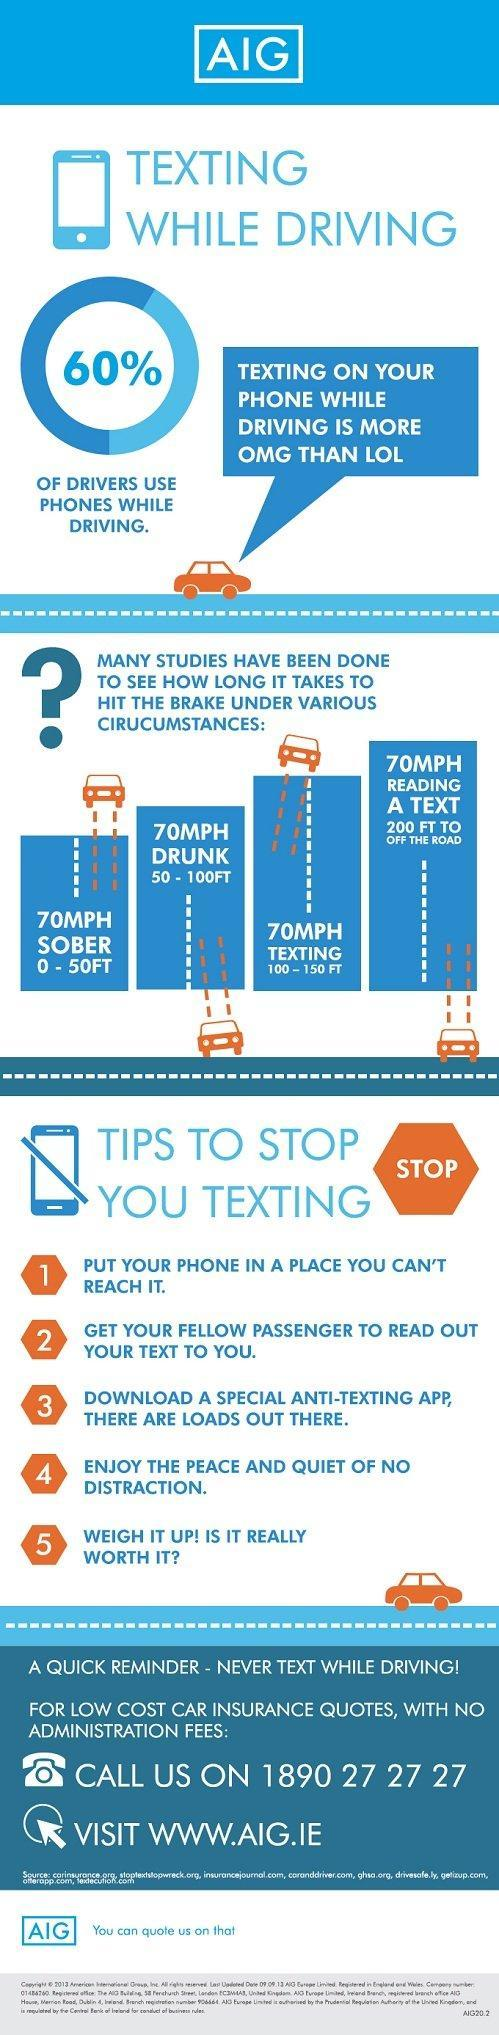What is the inverse percentage of people who uses phone while driving?
Answer the question with a short phrase. 40 How long it takes for the driver to put the brake while texting? 100 - 150 FT 